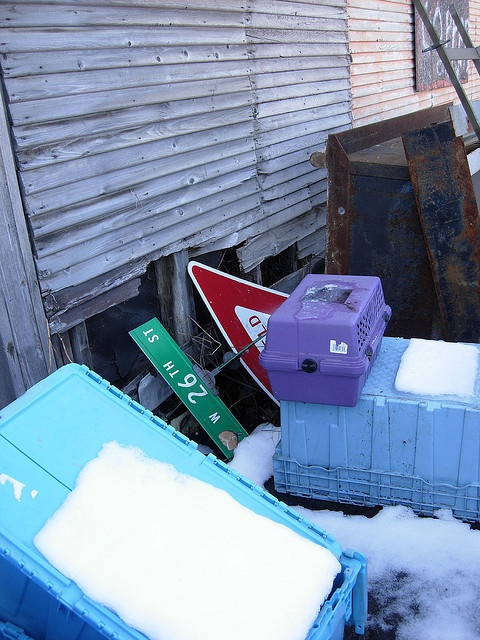Describe the objects in this image and their specific colors. I can see various objects in this image with different colors. 